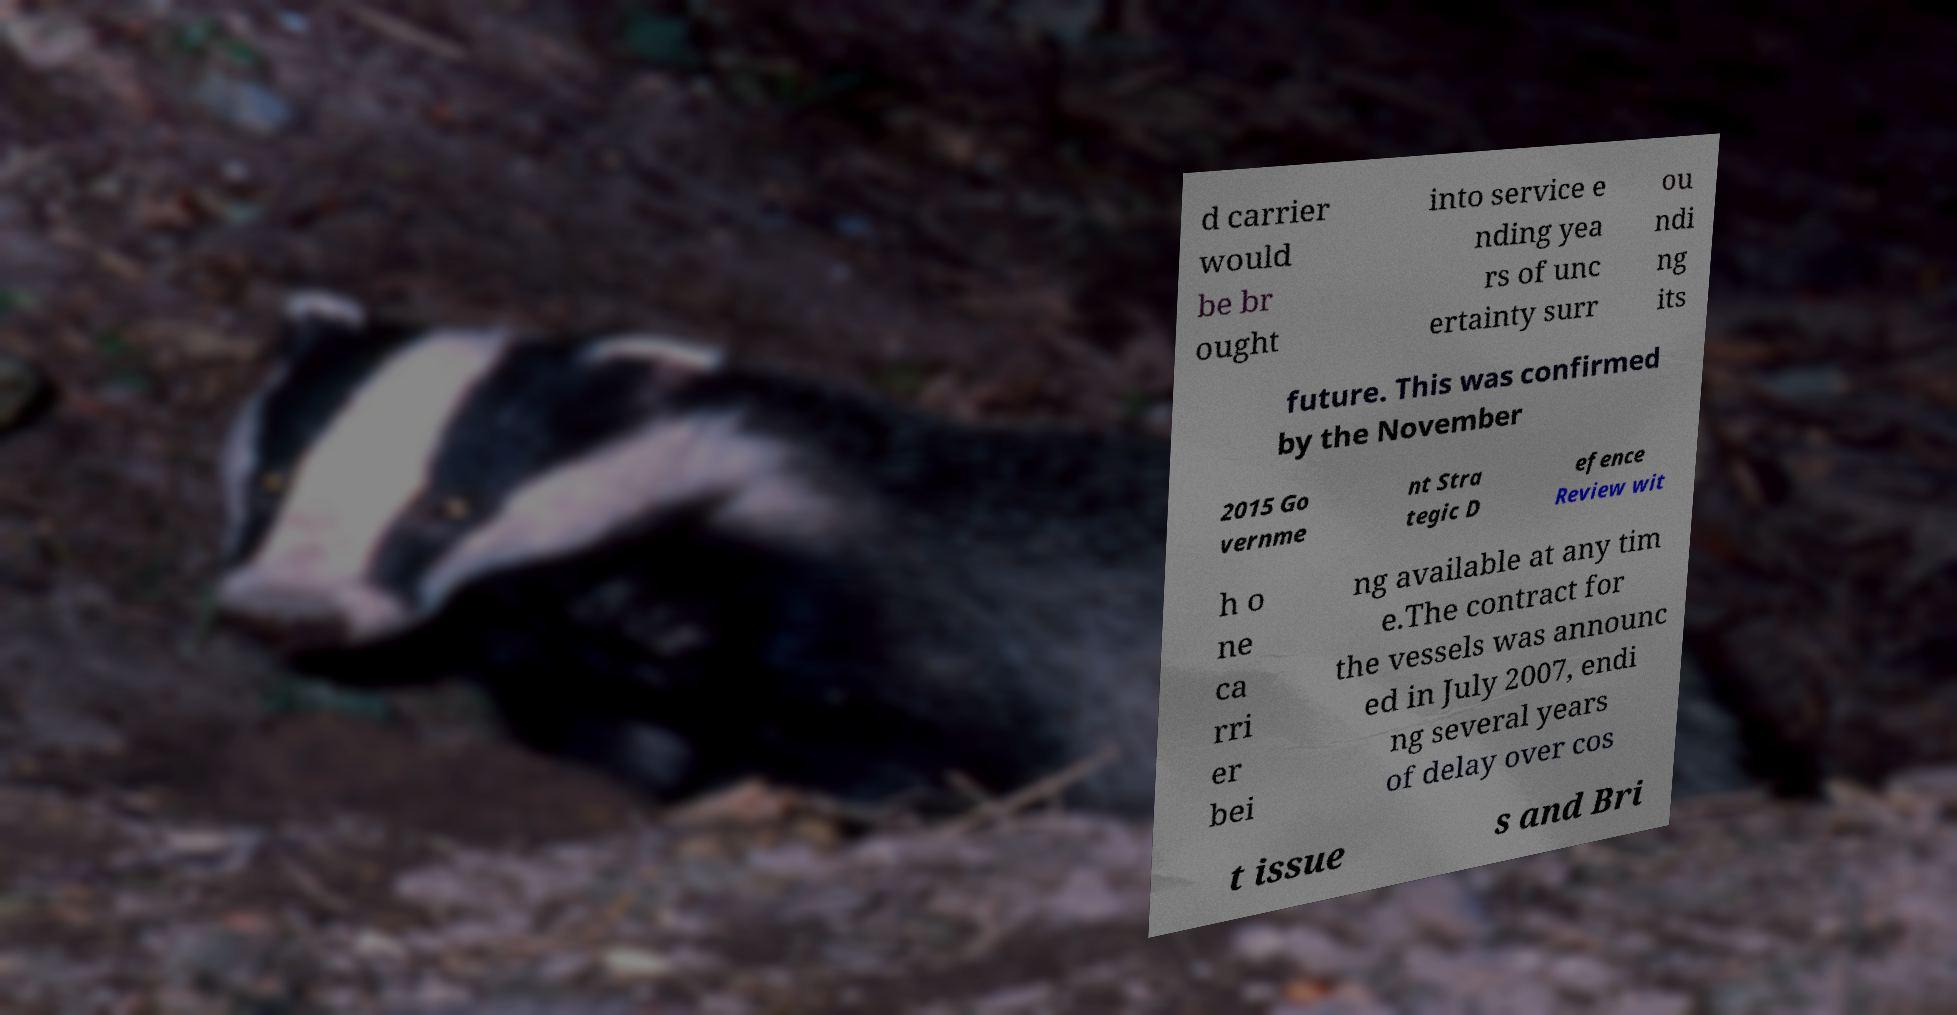Could you assist in decoding the text presented in this image and type it out clearly? d carrier would be br ought into service e nding yea rs of unc ertainty surr ou ndi ng its future. This was confirmed by the November 2015 Go vernme nt Stra tegic D efence Review wit h o ne ca rri er bei ng available at any tim e.The contract for the vessels was announc ed in July 2007, endi ng several years of delay over cos t issue s and Bri 